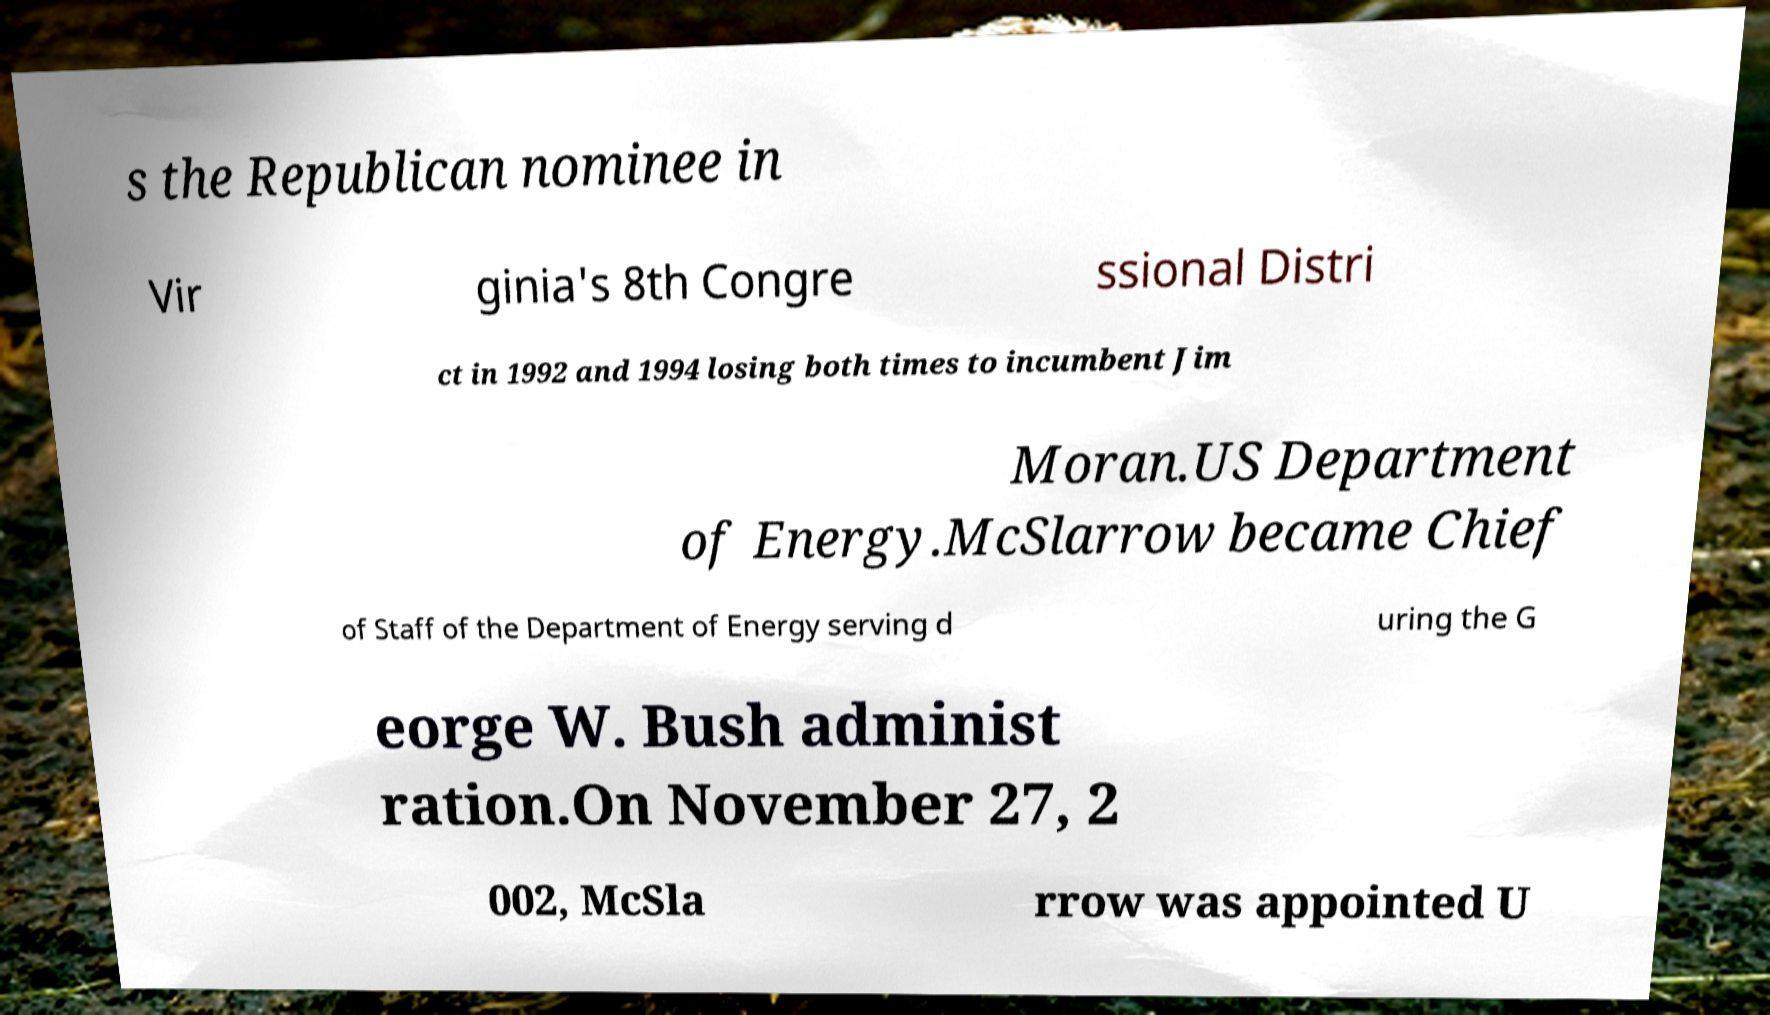Can you read and provide the text displayed in the image?This photo seems to have some interesting text. Can you extract and type it out for me? s the Republican nominee in Vir ginia's 8th Congre ssional Distri ct in 1992 and 1994 losing both times to incumbent Jim Moran.US Department of Energy.McSlarrow became Chief of Staff of the Department of Energy serving d uring the G eorge W. Bush administ ration.On November 27, 2 002, McSla rrow was appointed U 